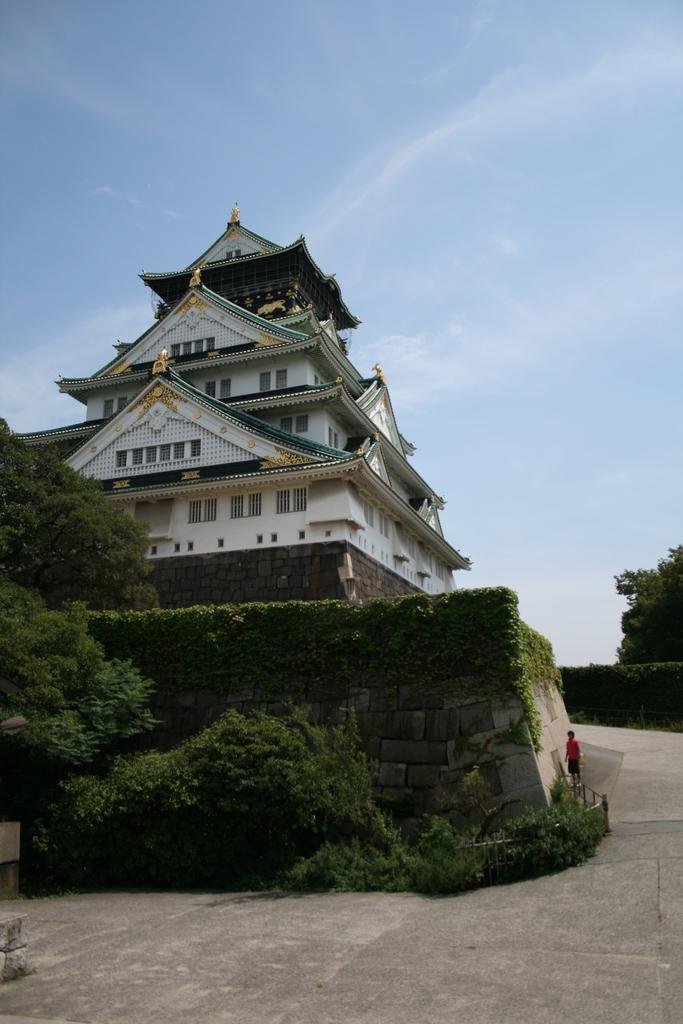What structure is the main focus of the image? There is a building in the image. What is located in front of the building? There is a tree in front of the building. What type of plant can be seen on the wall in the image? There is a creeper plant on the wall in the image. Can you describe the person in the image? A person is standing near the wall. What can be seen in the background of the image? The sky is visible in the background of the image. How many goldfish are swimming in the building's fountain in the image? There is no fountain or goldfish present in the image. What type of babies are playing near the tree in the image? There are no babies present in the image. 